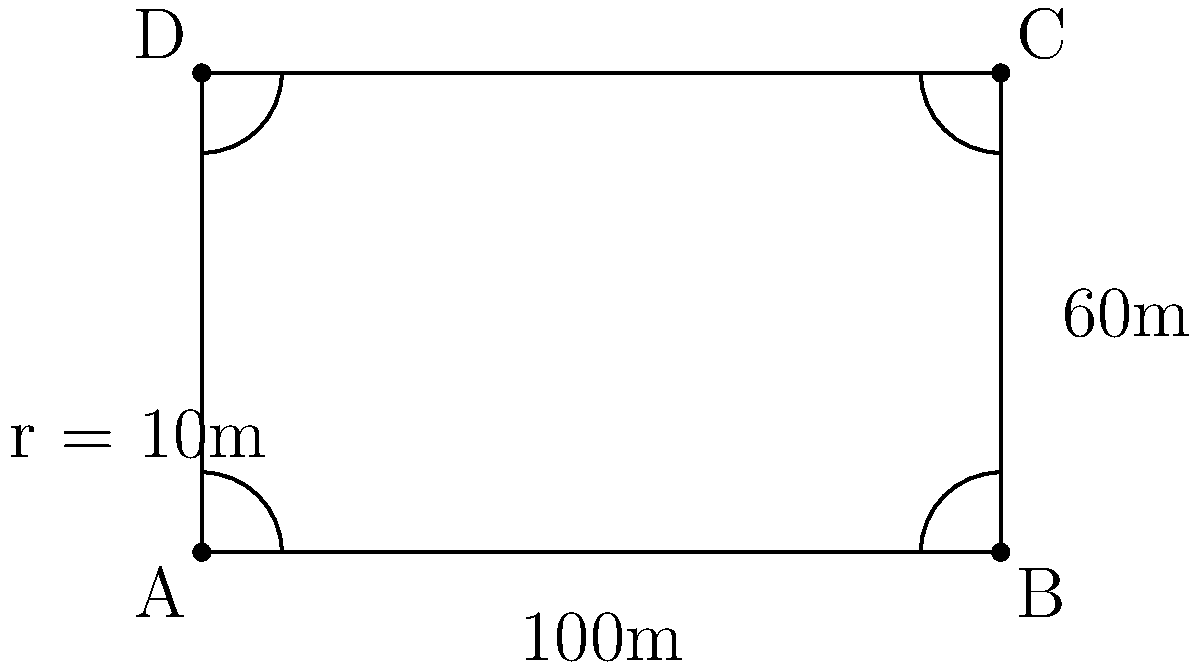You're designing a new football field for your hometown in Andhra Pradesh. The field is rectangular with circular arcs at each corner, as shown in the diagram. The length of the field is 100m, the width is 60m, and the radius of each circular arc is 10m. Calculate the total area of the playing surface. Let's approach this step-by-step:

1) First, calculate the area of the full rectangle:
   $A_{rectangle} = 100m \times 60m = 6000m^2$

2) Now, we need to subtract the area of the four corners that are cut off by the circular arcs. Each of these is a quarter of a square.
   Area of one square corner: $10m \times 10m = 100m^2$
   Area of one quarter square: $100m^2 \div 4 = 25m^2$
   Total area of four corners: $25m^2 \times 4 = 100m^2$

3) Next, we need to add back the area of the four circular arcs.
   Area of a full circle with radius 10m: $\pi r^2 = \pi \times 10^2 = 100\pi m^2$
   Area of a quarter circle: $100\pi m^2 \div 4 = 25\pi m^2$
   Total area of four quarter circles: $25\pi m^2 \times 4 = 100\pi m^2$

4) Now we can put it all together:
   Total Area = Area of rectangle - Area of square corners + Area of circular arcs
   $A_{total} = 6000m^2 - 100m^2 + 100\pi m^2$
   $A_{total} = 5900m^2 + 100\pi m^2$
   $A_{total} = 5900m^2 + 314.16m^2$ (using $\pi \approx 3.1416$)
   $A_{total} = 6214.16m^2$

Therefore, the total area of the playing surface is approximately 6214.16 square meters.
Answer: $6214.16m^2$ 